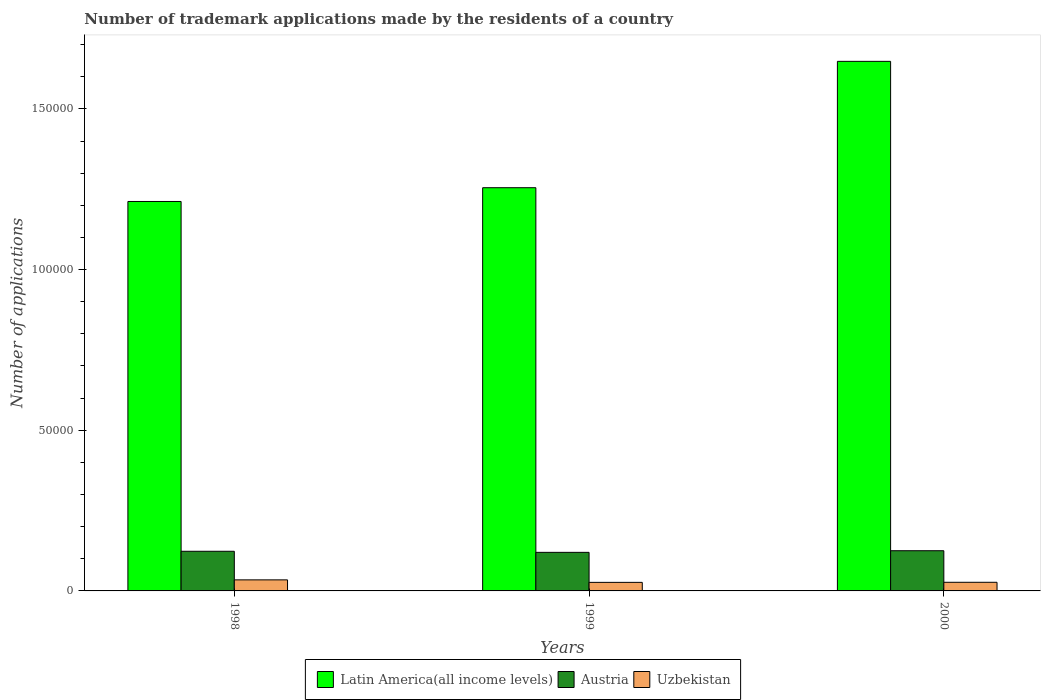How many different coloured bars are there?
Offer a terse response. 3. How many groups of bars are there?
Make the answer very short. 3. Are the number of bars per tick equal to the number of legend labels?
Your response must be concise. Yes. Are the number of bars on each tick of the X-axis equal?
Your answer should be compact. Yes. How many bars are there on the 2nd tick from the left?
Ensure brevity in your answer.  3. In how many cases, is the number of bars for a given year not equal to the number of legend labels?
Ensure brevity in your answer.  0. What is the number of trademark applications made by the residents in Latin America(all income levels) in 2000?
Provide a succinct answer. 1.65e+05. Across all years, what is the maximum number of trademark applications made by the residents in Austria?
Your answer should be compact. 1.25e+04. Across all years, what is the minimum number of trademark applications made by the residents in Austria?
Your answer should be compact. 1.20e+04. In which year was the number of trademark applications made by the residents in Austria minimum?
Keep it short and to the point. 1999. What is the total number of trademark applications made by the residents in Latin America(all income levels) in the graph?
Offer a terse response. 4.11e+05. What is the difference between the number of trademark applications made by the residents in Latin America(all income levels) in 1998 and that in 2000?
Offer a very short reply. -4.36e+04. What is the difference between the number of trademark applications made by the residents in Latin America(all income levels) in 2000 and the number of trademark applications made by the residents in Austria in 1998?
Make the answer very short. 1.52e+05. What is the average number of trademark applications made by the residents in Austria per year?
Keep it short and to the point. 1.23e+04. In the year 1999, what is the difference between the number of trademark applications made by the residents in Uzbekistan and number of trademark applications made by the residents in Austria?
Give a very brief answer. -9343. In how many years, is the number of trademark applications made by the residents in Austria greater than 70000?
Make the answer very short. 0. What is the ratio of the number of trademark applications made by the residents in Uzbekistan in 1998 to that in 2000?
Give a very brief answer. 1.28. Is the number of trademark applications made by the residents in Austria in 1999 less than that in 2000?
Make the answer very short. Yes. Is the difference between the number of trademark applications made by the residents in Uzbekistan in 1998 and 2000 greater than the difference between the number of trademark applications made by the residents in Austria in 1998 and 2000?
Ensure brevity in your answer.  Yes. What is the difference between the highest and the second highest number of trademark applications made by the residents in Austria?
Provide a succinct answer. 169. What is the difference between the highest and the lowest number of trademark applications made by the residents in Austria?
Keep it short and to the point. 502. In how many years, is the number of trademark applications made by the residents in Austria greater than the average number of trademark applications made by the residents in Austria taken over all years?
Your response must be concise. 2. Is the sum of the number of trademark applications made by the residents in Uzbekistan in 1998 and 1999 greater than the maximum number of trademark applications made by the residents in Latin America(all income levels) across all years?
Ensure brevity in your answer.  No. What does the 1st bar from the left in 2000 represents?
Provide a short and direct response. Latin America(all income levels). What does the 1st bar from the right in 2000 represents?
Your response must be concise. Uzbekistan. What is the difference between two consecutive major ticks on the Y-axis?
Make the answer very short. 5.00e+04. Are the values on the major ticks of Y-axis written in scientific E-notation?
Your answer should be very brief. No. Does the graph contain any zero values?
Your answer should be compact. No. Where does the legend appear in the graph?
Your response must be concise. Bottom center. What is the title of the graph?
Offer a terse response. Number of trademark applications made by the residents of a country. What is the label or title of the Y-axis?
Your answer should be very brief. Number of applications. What is the Number of applications of Latin America(all income levels) in 1998?
Keep it short and to the point. 1.21e+05. What is the Number of applications of Austria in 1998?
Offer a very short reply. 1.23e+04. What is the Number of applications of Uzbekistan in 1998?
Make the answer very short. 3441. What is the Number of applications in Latin America(all income levels) in 1999?
Your answer should be very brief. 1.25e+05. What is the Number of applications of Austria in 1999?
Offer a very short reply. 1.20e+04. What is the Number of applications of Uzbekistan in 1999?
Ensure brevity in your answer.  2662. What is the Number of applications of Latin America(all income levels) in 2000?
Keep it short and to the point. 1.65e+05. What is the Number of applications of Austria in 2000?
Provide a short and direct response. 1.25e+04. What is the Number of applications of Uzbekistan in 2000?
Your response must be concise. 2686. Across all years, what is the maximum Number of applications of Latin America(all income levels)?
Provide a succinct answer. 1.65e+05. Across all years, what is the maximum Number of applications of Austria?
Keep it short and to the point. 1.25e+04. Across all years, what is the maximum Number of applications in Uzbekistan?
Your answer should be very brief. 3441. Across all years, what is the minimum Number of applications in Latin America(all income levels)?
Keep it short and to the point. 1.21e+05. Across all years, what is the minimum Number of applications of Austria?
Offer a terse response. 1.20e+04. Across all years, what is the minimum Number of applications in Uzbekistan?
Keep it short and to the point. 2662. What is the total Number of applications in Latin America(all income levels) in the graph?
Keep it short and to the point. 4.11e+05. What is the total Number of applications in Austria in the graph?
Give a very brief answer. 3.68e+04. What is the total Number of applications of Uzbekistan in the graph?
Your answer should be compact. 8789. What is the difference between the Number of applications in Latin America(all income levels) in 1998 and that in 1999?
Provide a succinct answer. -4286. What is the difference between the Number of applications in Austria in 1998 and that in 1999?
Provide a succinct answer. 333. What is the difference between the Number of applications of Uzbekistan in 1998 and that in 1999?
Your response must be concise. 779. What is the difference between the Number of applications of Latin America(all income levels) in 1998 and that in 2000?
Provide a succinct answer. -4.36e+04. What is the difference between the Number of applications in Austria in 1998 and that in 2000?
Offer a terse response. -169. What is the difference between the Number of applications in Uzbekistan in 1998 and that in 2000?
Make the answer very short. 755. What is the difference between the Number of applications in Latin America(all income levels) in 1999 and that in 2000?
Provide a succinct answer. -3.93e+04. What is the difference between the Number of applications in Austria in 1999 and that in 2000?
Your response must be concise. -502. What is the difference between the Number of applications in Latin America(all income levels) in 1998 and the Number of applications in Austria in 1999?
Provide a short and direct response. 1.09e+05. What is the difference between the Number of applications of Latin America(all income levels) in 1998 and the Number of applications of Uzbekistan in 1999?
Keep it short and to the point. 1.19e+05. What is the difference between the Number of applications in Austria in 1998 and the Number of applications in Uzbekistan in 1999?
Ensure brevity in your answer.  9676. What is the difference between the Number of applications in Latin America(all income levels) in 1998 and the Number of applications in Austria in 2000?
Your response must be concise. 1.09e+05. What is the difference between the Number of applications of Latin America(all income levels) in 1998 and the Number of applications of Uzbekistan in 2000?
Your answer should be compact. 1.19e+05. What is the difference between the Number of applications of Austria in 1998 and the Number of applications of Uzbekistan in 2000?
Your answer should be very brief. 9652. What is the difference between the Number of applications in Latin America(all income levels) in 1999 and the Number of applications in Austria in 2000?
Offer a very short reply. 1.13e+05. What is the difference between the Number of applications in Latin America(all income levels) in 1999 and the Number of applications in Uzbekistan in 2000?
Give a very brief answer. 1.23e+05. What is the difference between the Number of applications of Austria in 1999 and the Number of applications of Uzbekistan in 2000?
Offer a very short reply. 9319. What is the average Number of applications of Latin America(all income levels) per year?
Your response must be concise. 1.37e+05. What is the average Number of applications of Austria per year?
Give a very brief answer. 1.23e+04. What is the average Number of applications in Uzbekistan per year?
Offer a terse response. 2929.67. In the year 1998, what is the difference between the Number of applications of Latin America(all income levels) and Number of applications of Austria?
Keep it short and to the point. 1.09e+05. In the year 1998, what is the difference between the Number of applications in Latin America(all income levels) and Number of applications in Uzbekistan?
Keep it short and to the point. 1.18e+05. In the year 1998, what is the difference between the Number of applications of Austria and Number of applications of Uzbekistan?
Make the answer very short. 8897. In the year 1999, what is the difference between the Number of applications of Latin America(all income levels) and Number of applications of Austria?
Make the answer very short. 1.13e+05. In the year 1999, what is the difference between the Number of applications of Latin America(all income levels) and Number of applications of Uzbekistan?
Keep it short and to the point. 1.23e+05. In the year 1999, what is the difference between the Number of applications of Austria and Number of applications of Uzbekistan?
Make the answer very short. 9343. In the year 2000, what is the difference between the Number of applications in Latin America(all income levels) and Number of applications in Austria?
Give a very brief answer. 1.52e+05. In the year 2000, what is the difference between the Number of applications in Latin America(all income levels) and Number of applications in Uzbekistan?
Keep it short and to the point. 1.62e+05. In the year 2000, what is the difference between the Number of applications of Austria and Number of applications of Uzbekistan?
Offer a very short reply. 9821. What is the ratio of the Number of applications of Latin America(all income levels) in 1998 to that in 1999?
Keep it short and to the point. 0.97. What is the ratio of the Number of applications of Austria in 1998 to that in 1999?
Offer a very short reply. 1.03. What is the ratio of the Number of applications of Uzbekistan in 1998 to that in 1999?
Ensure brevity in your answer.  1.29. What is the ratio of the Number of applications of Latin America(all income levels) in 1998 to that in 2000?
Your answer should be very brief. 0.74. What is the ratio of the Number of applications in Austria in 1998 to that in 2000?
Give a very brief answer. 0.99. What is the ratio of the Number of applications in Uzbekistan in 1998 to that in 2000?
Your answer should be very brief. 1.28. What is the ratio of the Number of applications of Latin America(all income levels) in 1999 to that in 2000?
Give a very brief answer. 0.76. What is the ratio of the Number of applications in Austria in 1999 to that in 2000?
Your answer should be compact. 0.96. What is the ratio of the Number of applications in Uzbekistan in 1999 to that in 2000?
Give a very brief answer. 0.99. What is the difference between the highest and the second highest Number of applications of Latin America(all income levels)?
Provide a short and direct response. 3.93e+04. What is the difference between the highest and the second highest Number of applications of Austria?
Your answer should be very brief. 169. What is the difference between the highest and the second highest Number of applications of Uzbekistan?
Make the answer very short. 755. What is the difference between the highest and the lowest Number of applications in Latin America(all income levels)?
Your response must be concise. 4.36e+04. What is the difference between the highest and the lowest Number of applications of Austria?
Provide a short and direct response. 502. What is the difference between the highest and the lowest Number of applications in Uzbekistan?
Offer a terse response. 779. 